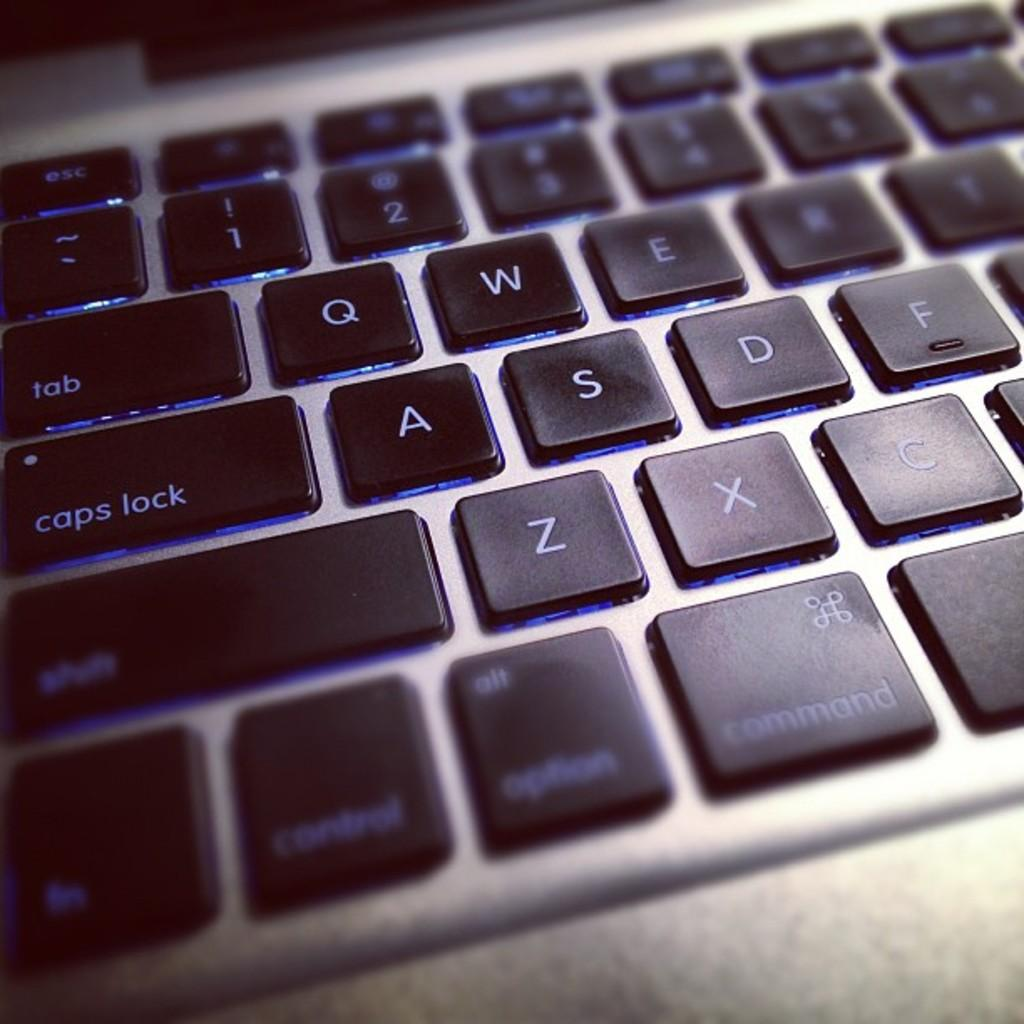<image>
Relay a brief, clear account of the picture shown. A close up on a keyboard which has buttons visible such as tab and caps lock. 